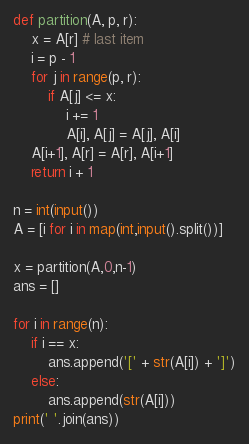<code> <loc_0><loc_0><loc_500><loc_500><_Python_>def partition(A, p, r):
    x = A[r] # last item
    i = p - 1
    for j in range(p, r):
        if A[j] <= x:
            i += 1
            A[i], A[j] = A[j], A[i]
    A[i+1], A[r] = A[r], A[i+1]
    return i + 1

n = int(input())
A = [i for i in map(int,input().split())]

x = partition(A,0,n-1)
ans = []

for i in range(n):
    if i == x:
        ans.append('[' + str(A[i]) + ']')
    else:
        ans.append(str(A[i]))
print(' '.join(ans))
</code> 